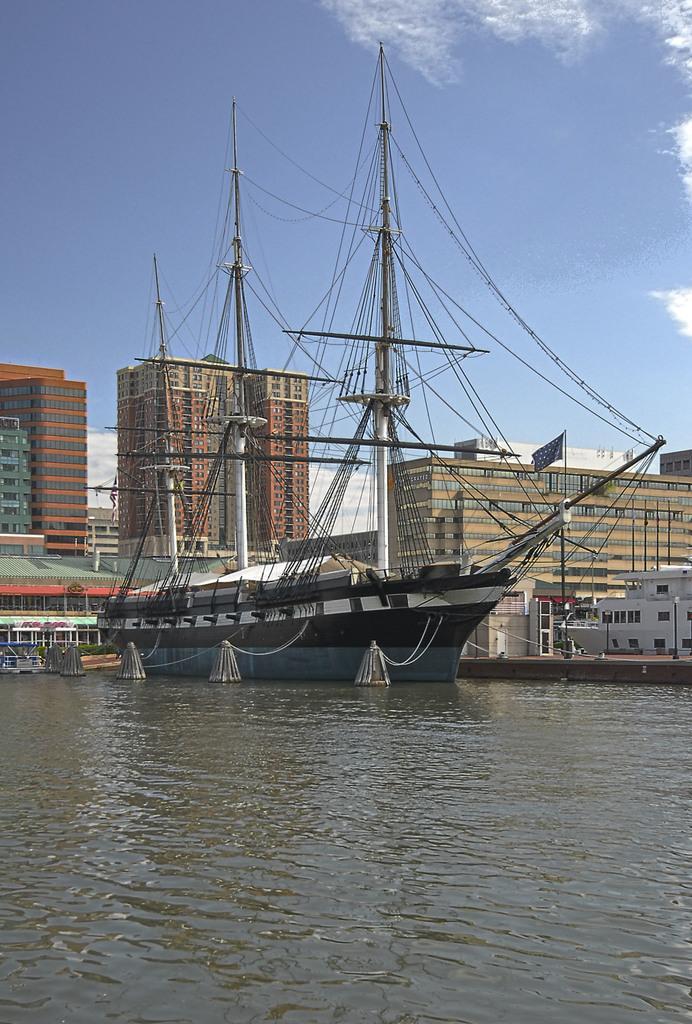Please provide a concise description of this image. At the bottom of the picture, we see water and this water might be in the canal. In the middle of the picture, we see a boat. There are buildings and poles in the background. We even see a flag in the background. At the top of the picture, we see the sky, which is blue in color. 